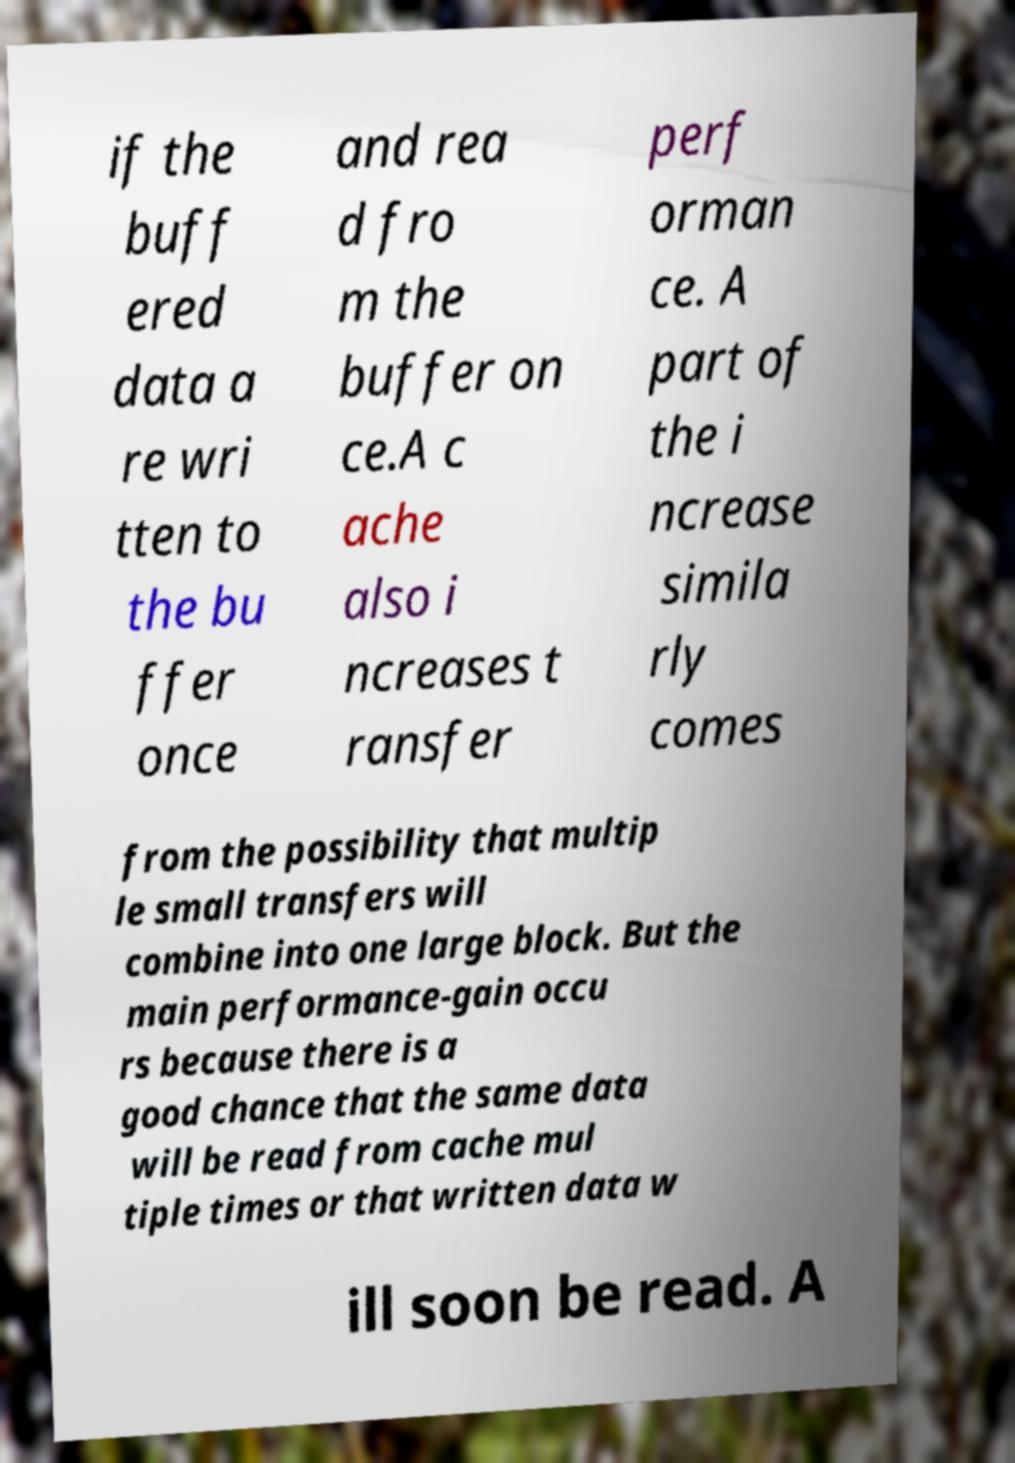Please read and relay the text visible in this image. What does it say? if the buff ered data a re wri tten to the bu ffer once and rea d fro m the buffer on ce.A c ache also i ncreases t ransfer perf orman ce. A part of the i ncrease simila rly comes from the possibility that multip le small transfers will combine into one large block. But the main performance-gain occu rs because there is a good chance that the same data will be read from cache mul tiple times or that written data w ill soon be read. A 